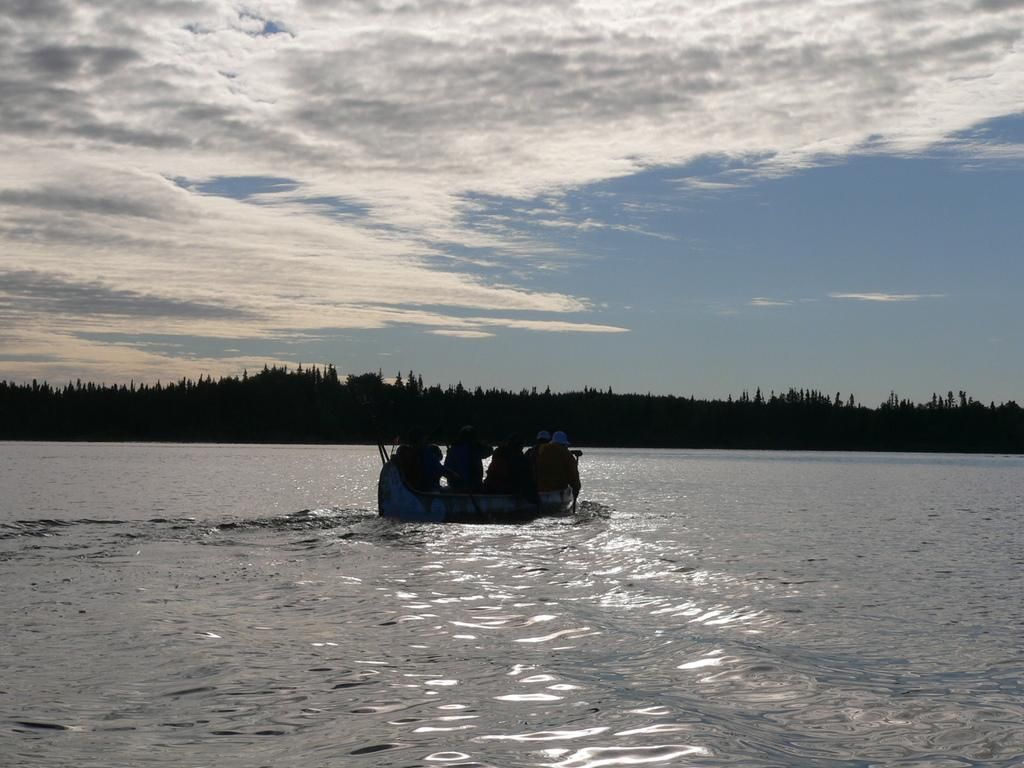What is the main subject of the image? The main subject of the image is a boat. Where is the boat located? The boat is on the water. Are there any people in the image? Yes, there are people sitting in the boat. What can be seen in the background of the image? There are many trees and clouds visible in the background, and the sky is also visible. What type of mint is being distributed on the railway in the image? There is no mint or railway present in the image; it features a boat on the water with people sitting in it. 